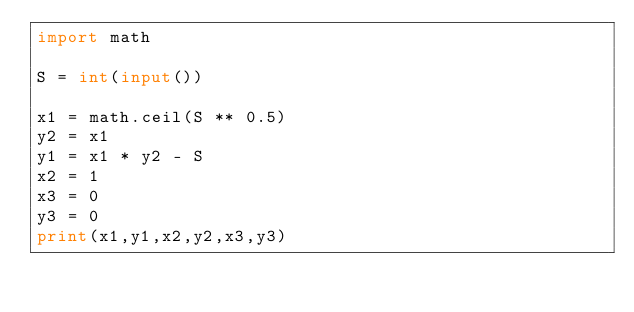Convert code to text. <code><loc_0><loc_0><loc_500><loc_500><_Python_>import math

S = int(input())

x1 = math.ceil(S ** 0.5)
y2 = x1
y1 = x1 * y2 - S
x2 = 1
x3 = 0
y3 = 0
print(x1,y1,x2,y2,x3,y3)
</code> 